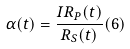Convert formula to latex. <formula><loc_0><loc_0><loc_500><loc_500>\alpha ( t ) = \frac { I R _ { P } ( t ) } { R _ { S } ( t ) } ( 6 )</formula> 